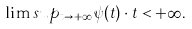Convert formula to latex. <formula><loc_0><loc_0><loc_500><loc_500>\lim s u p _ { t \to + \infty } { \psi ( t ) } \cdot { t } < + \infty .</formula> 